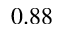Convert formula to latex. <formula><loc_0><loc_0><loc_500><loc_500>0 . 8 8</formula> 